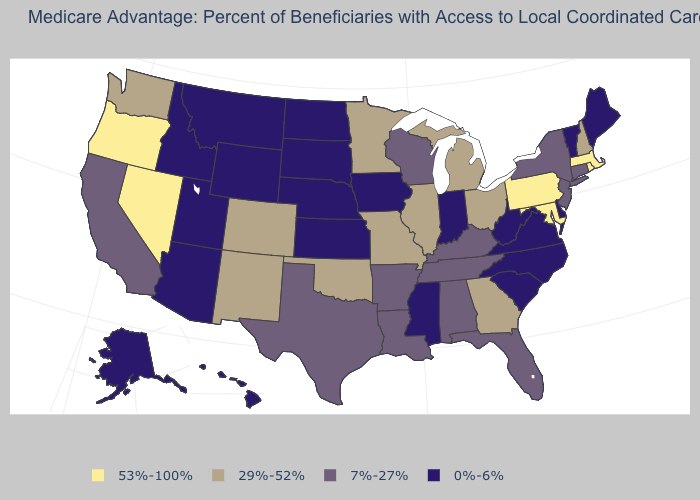What is the value of Rhode Island?
Keep it brief. 53%-100%. Which states have the lowest value in the USA?
Give a very brief answer. Alaska, Arizona, Delaware, Hawaii, Iowa, Idaho, Indiana, Kansas, Maine, Mississippi, Montana, North Carolina, North Dakota, Nebraska, South Carolina, South Dakota, Utah, Virginia, Vermont, West Virginia, Wyoming. What is the value of Utah?
Answer briefly. 0%-6%. What is the value of Kentucky?
Concise answer only. 7%-27%. What is the value of South Dakota?
Answer briefly. 0%-6%. Name the states that have a value in the range 53%-100%?
Give a very brief answer. Massachusetts, Maryland, Nevada, Oregon, Pennsylvania, Rhode Island. Does the first symbol in the legend represent the smallest category?
Answer briefly. No. Name the states that have a value in the range 0%-6%?
Write a very short answer. Alaska, Arizona, Delaware, Hawaii, Iowa, Idaho, Indiana, Kansas, Maine, Mississippi, Montana, North Carolina, North Dakota, Nebraska, South Carolina, South Dakota, Utah, Virginia, Vermont, West Virginia, Wyoming. What is the value of Kansas?
Give a very brief answer. 0%-6%. Name the states that have a value in the range 0%-6%?
Concise answer only. Alaska, Arizona, Delaware, Hawaii, Iowa, Idaho, Indiana, Kansas, Maine, Mississippi, Montana, North Carolina, North Dakota, Nebraska, South Carolina, South Dakota, Utah, Virginia, Vermont, West Virginia, Wyoming. Name the states that have a value in the range 7%-27%?
Short answer required. Alabama, Arkansas, California, Connecticut, Florida, Kentucky, Louisiana, New Jersey, New York, Tennessee, Texas, Wisconsin. What is the highest value in states that border Rhode Island?
Quick response, please. 53%-100%. Is the legend a continuous bar?
Give a very brief answer. No. What is the value of Arizona?
Be succinct. 0%-6%. What is the value of New Jersey?
Short answer required. 7%-27%. 